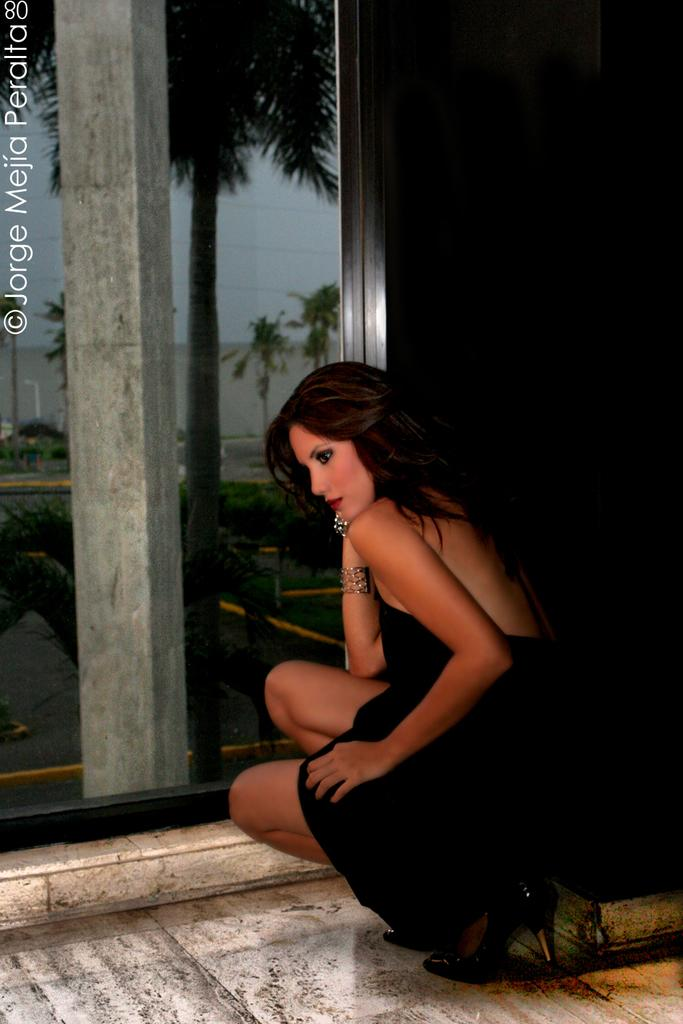Who is the main subject in the image? There is a woman in the image. What position is the woman in? The woman is sitting in a squat position. Where is the woman located in the image? The woman is in a glass window. What can be seen through the glass window? Trees, a wall, and the clear sky are visible through the glass window. How many candles are on the woman's birthday cake in the image? There is no birthday cake or candles present in the image. What is the woman doing to her stomach in the image? There is no indication of the woman interacting with her stomach in the image. 